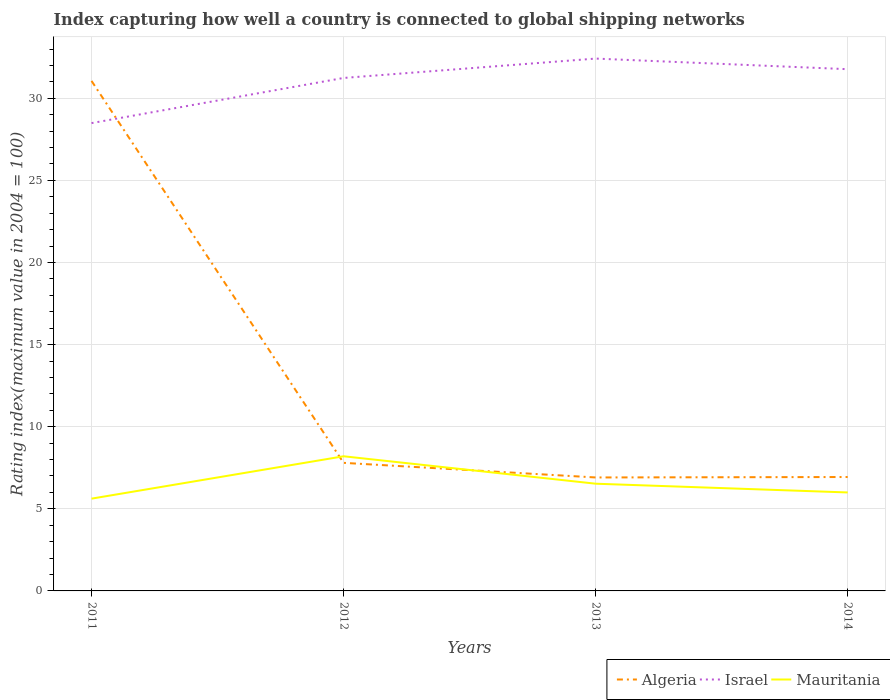Is the number of lines equal to the number of legend labels?
Give a very brief answer. Yes. Across all years, what is the maximum rating index in Mauritania?
Offer a very short reply. 5.62. What is the total rating index in Mauritania in the graph?
Keep it short and to the point. 0.53. What is the difference between the highest and the second highest rating index in Israel?
Provide a short and direct response. 3.93. Does the graph contain any zero values?
Make the answer very short. No. Does the graph contain grids?
Offer a terse response. Yes. What is the title of the graph?
Offer a very short reply. Index capturing how well a country is connected to global shipping networks. What is the label or title of the Y-axis?
Give a very brief answer. Rating index(maximum value in 2004 = 100). What is the Rating index(maximum value in 2004 = 100) of Algeria in 2011?
Keep it short and to the point. 31.06. What is the Rating index(maximum value in 2004 = 100) of Israel in 2011?
Offer a terse response. 28.49. What is the Rating index(maximum value in 2004 = 100) in Mauritania in 2011?
Your answer should be very brief. 5.62. What is the Rating index(maximum value in 2004 = 100) of Israel in 2012?
Offer a very short reply. 31.24. What is the Rating index(maximum value in 2004 = 100) in Algeria in 2013?
Offer a very short reply. 6.91. What is the Rating index(maximum value in 2004 = 100) in Israel in 2013?
Provide a short and direct response. 32.42. What is the Rating index(maximum value in 2004 = 100) of Mauritania in 2013?
Your answer should be compact. 6.53. What is the Rating index(maximum value in 2004 = 100) of Algeria in 2014?
Provide a short and direct response. 6.94. What is the Rating index(maximum value in 2004 = 100) of Israel in 2014?
Offer a very short reply. 31.77. What is the Rating index(maximum value in 2004 = 100) of Mauritania in 2014?
Your response must be concise. 6. Across all years, what is the maximum Rating index(maximum value in 2004 = 100) of Algeria?
Offer a very short reply. 31.06. Across all years, what is the maximum Rating index(maximum value in 2004 = 100) in Israel?
Keep it short and to the point. 32.42. Across all years, what is the maximum Rating index(maximum value in 2004 = 100) in Mauritania?
Your answer should be compact. 8.2. Across all years, what is the minimum Rating index(maximum value in 2004 = 100) of Algeria?
Ensure brevity in your answer.  6.91. Across all years, what is the minimum Rating index(maximum value in 2004 = 100) in Israel?
Make the answer very short. 28.49. Across all years, what is the minimum Rating index(maximum value in 2004 = 100) of Mauritania?
Offer a terse response. 5.62. What is the total Rating index(maximum value in 2004 = 100) of Algeria in the graph?
Make the answer very short. 52.71. What is the total Rating index(maximum value in 2004 = 100) of Israel in the graph?
Your answer should be very brief. 123.92. What is the total Rating index(maximum value in 2004 = 100) in Mauritania in the graph?
Provide a succinct answer. 26.35. What is the difference between the Rating index(maximum value in 2004 = 100) in Algeria in 2011 and that in 2012?
Offer a terse response. 23.26. What is the difference between the Rating index(maximum value in 2004 = 100) of Israel in 2011 and that in 2012?
Your response must be concise. -2.75. What is the difference between the Rating index(maximum value in 2004 = 100) in Mauritania in 2011 and that in 2012?
Offer a terse response. -2.58. What is the difference between the Rating index(maximum value in 2004 = 100) in Algeria in 2011 and that in 2013?
Keep it short and to the point. 24.15. What is the difference between the Rating index(maximum value in 2004 = 100) of Israel in 2011 and that in 2013?
Your answer should be compact. -3.93. What is the difference between the Rating index(maximum value in 2004 = 100) of Mauritania in 2011 and that in 2013?
Offer a very short reply. -0.91. What is the difference between the Rating index(maximum value in 2004 = 100) in Algeria in 2011 and that in 2014?
Your response must be concise. 24.12. What is the difference between the Rating index(maximum value in 2004 = 100) of Israel in 2011 and that in 2014?
Keep it short and to the point. -3.28. What is the difference between the Rating index(maximum value in 2004 = 100) in Mauritania in 2011 and that in 2014?
Offer a terse response. -0.38. What is the difference between the Rating index(maximum value in 2004 = 100) in Algeria in 2012 and that in 2013?
Give a very brief answer. 0.89. What is the difference between the Rating index(maximum value in 2004 = 100) in Israel in 2012 and that in 2013?
Ensure brevity in your answer.  -1.18. What is the difference between the Rating index(maximum value in 2004 = 100) of Mauritania in 2012 and that in 2013?
Give a very brief answer. 1.67. What is the difference between the Rating index(maximum value in 2004 = 100) of Algeria in 2012 and that in 2014?
Provide a succinct answer. 0.86. What is the difference between the Rating index(maximum value in 2004 = 100) in Israel in 2012 and that in 2014?
Provide a short and direct response. -0.53. What is the difference between the Rating index(maximum value in 2004 = 100) in Mauritania in 2012 and that in 2014?
Ensure brevity in your answer.  2.2. What is the difference between the Rating index(maximum value in 2004 = 100) of Algeria in 2013 and that in 2014?
Your answer should be very brief. -0.03. What is the difference between the Rating index(maximum value in 2004 = 100) in Israel in 2013 and that in 2014?
Make the answer very short. 0.65. What is the difference between the Rating index(maximum value in 2004 = 100) of Mauritania in 2013 and that in 2014?
Your answer should be compact. 0.53. What is the difference between the Rating index(maximum value in 2004 = 100) in Algeria in 2011 and the Rating index(maximum value in 2004 = 100) in Israel in 2012?
Your answer should be very brief. -0.18. What is the difference between the Rating index(maximum value in 2004 = 100) of Algeria in 2011 and the Rating index(maximum value in 2004 = 100) of Mauritania in 2012?
Your response must be concise. 22.86. What is the difference between the Rating index(maximum value in 2004 = 100) in Israel in 2011 and the Rating index(maximum value in 2004 = 100) in Mauritania in 2012?
Keep it short and to the point. 20.29. What is the difference between the Rating index(maximum value in 2004 = 100) in Algeria in 2011 and the Rating index(maximum value in 2004 = 100) in Israel in 2013?
Offer a terse response. -1.36. What is the difference between the Rating index(maximum value in 2004 = 100) of Algeria in 2011 and the Rating index(maximum value in 2004 = 100) of Mauritania in 2013?
Your answer should be compact. 24.53. What is the difference between the Rating index(maximum value in 2004 = 100) of Israel in 2011 and the Rating index(maximum value in 2004 = 100) of Mauritania in 2013?
Your response must be concise. 21.96. What is the difference between the Rating index(maximum value in 2004 = 100) of Algeria in 2011 and the Rating index(maximum value in 2004 = 100) of Israel in 2014?
Give a very brief answer. -0.71. What is the difference between the Rating index(maximum value in 2004 = 100) in Algeria in 2011 and the Rating index(maximum value in 2004 = 100) in Mauritania in 2014?
Offer a terse response. 25.06. What is the difference between the Rating index(maximum value in 2004 = 100) of Israel in 2011 and the Rating index(maximum value in 2004 = 100) of Mauritania in 2014?
Provide a short and direct response. 22.49. What is the difference between the Rating index(maximum value in 2004 = 100) in Algeria in 2012 and the Rating index(maximum value in 2004 = 100) in Israel in 2013?
Provide a succinct answer. -24.62. What is the difference between the Rating index(maximum value in 2004 = 100) in Algeria in 2012 and the Rating index(maximum value in 2004 = 100) in Mauritania in 2013?
Your response must be concise. 1.27. What is the difference between the Rating index(maximum value in 2004 = 100) of Israel in 2012 and the Rating index(maximum value in 2004 = 100) of Mauritania in 2013?
Ensure brevity in your answer.  24.71. What is the difference between the Rating index(maximum value in 2004 = 100) of Algeria in 2012 and the Rating index(maximum value in 2004 = 100) of Israel in 2014?
Keep it short and to the point. -23.97. What is the difference between the Rating index(maximum value in 2004 = 100) in Algeria in 2012 and the Rating index(maximum value in 2004 = 100) in Mauritania in 2014?
Provide a short and direct response. 1.8. What is the difference between the Rating index(maximum value in 2004 = 100) of Israel in 2012 and the Rating index(maximum value in 2004 = 100) of Mauritania in 2014?
Your answer should be compact. 25.24. What is the difference between the Rating index(maximum value in 2004 = 100) of Algeria in 2013 and the Rating index(maximum value in 2004 = 100) of Israel in 2014?
Provide a short and direct response. -24.86. What is the difference between the Rating index(maximum value in 2004 = 100) of Algeria in 2013 and the Rating index(maximum value in 2004 = 100) of Mauritania in 2014?
Keep it short and to the point. 0.91. What is the difference between the Rating index(maximum value in 2004 = 100) of Israel in 2013 and the Rating index(maximum value in 2004 = 100) of Mauritania in 2014?
Keep it short and to the point. 26.42. What is the average Rating index(maximum value in 2004 = 100) of Algeria per year?
Offer a very short reply. 13.18. What is the average Rating index(maximum value in 2004 = 100) of Israel per year?
Your answer should be compact. 30.98. What is the average Rating index(maximum value in 2004 = 100) of Mauritania per year?
Offer a very short reply. 6.59. In the year 2011, what is the difference between the Rating index(maximum value in 2004 = 100) of Algeria and Rating index(maximum value in 2004 = 100) of Israel?
Your answer should be compact. 2.57. In the year 2011, what is the difference between the Rating index(maximum value in 2004 = 100) in Algeria and Rating index(maximum value in 2004 = 100) in Mauritania?
Offer a terse response. 25.44. In the year 2011, what is the difference between the Rating index(maximum value in 2004 = 100) of Israel and Rating index(maximum value in 2004 = 100) of Mauritania?
Offer a terse response. 22.87. In the year 2012, what is the difference between the Rating index(maximum value in 2004 = 100) of Algeria and Rating index(maximum value in 2004 = 100) of Israel?
Provide a succinct answer. -23.44. In the year 2012, what is the difference between the Rating index(maximum value in 2004 = 100) in Algeria and Rating index(maximum value in 2004 = 100) in Mauritania?
Offer a terse response. -0.4. In the year 2012, what is the difference between the Rating index(maximum value in 2004 = 100) in Israel and Rating index(maximum value in 2004 = 100) in Mauritania?
Your response must be concise. 23.04. In the year 2013, what is the difference between the Rating index(maximum value in 2004 = 100) in Algeria and Rating index(maximum value in 2004 = 100) in Israel?
Your response must be concise. -25.51. In the year 2013, what is the difference between the Rating index(maximum value in 2004 = 100) in Algeria and Rating index(maximum value in 2004 = 100) in Mauritania?
Provide a short and direct response. 0.38. In the year 2013, what is the difference between the Rating index(maximum value in 2004 = 100) in Israel and Rating index(maximum value in 2004 = 100) in Mauritania?
Provide a short and direct response. 25.89. In the year 2014, what is the difference between the Rating index(maximum value in 2004 = 100) of Algeria and Rating index(maximum value in 2004 = 100) of Israel?
Your answer should be very brief. -24.84. In the year 2014, what is the difference between the Rating index(maximum value in 2004 = 100) in Algeria and Rating index(maximum value in 2004 = 100) in Mauritania?
Make the answer very short. 0.94. In the year 2014, what is the difference between the Rating index(maximum value in 2004 = 100) of Israel and Rating index(maximum value in 2004 = 100) of Mauritania?
Give a very brief answer. 25.78. What is the ratio of the Rating index(maximum value in 2004 = 100) of Algeria in 2011 to that in 2012?
Make the answer very short. 3.98. What is the ratio of the Rating index(maximum value in 2004 = 100) in Israel in 2011 to that in 2012?
Offer a terse response. 0.91. What is the ratio of the Rating index(maximum value in 2004 = 100) of Mauritania in 2011 to that in 2012?
Provide a succinct answer. 0.69. What is the ratio of the Rating index(maximum value in 2004 = 100) in Algeria in 2011 to that in 2013?
Offer a very short reply. 4.49. What is the ratio of the Rating index(maximum value in 2004 = 100) of Israel in 2011 to that in 2013?
Offer a very short reply. 0.88. What is the ratio of the Rating index(maximum value in 2004 = 100) in Mauritania in 2011 to that in 2013?
Give a very brief answer. 0.86. What is the ratio of the Rating index(maximum value in 2004 = 100) of Algeria in 2011 to that in 2014?
Provide a succinct answer. 4.48. What is the ratio of the Rating index(maximum value in 2004 = 100) of Israel in 2011 to that in 2014?
Keep it short and to the point. 0.9. What is the ratio of the Rating index(maximum value in 2004 = 100) in Mauritania in 2011 to that in 2014?
Provide a succinct answer. 0.94. What is the ratio of the Rating index(maximum value in 2004 = 100) in Algeria in 2012 to that in 2013?
Your answer should be very brief. 1.13. What is the ratio of the Rating index(maximum value in 2004 = 100) of Israel in 2012 to that in 2013?
Keep it short and to the point. 0.96. What is the ratio of the Rating index(maximum value in 2004 = 100) in Mauritania in 2012 to that in 2013?
Ensure brevity in your answer.  1.26. What is the ratio of the Rating index(maximum value in 2004 = 100) of Algeria in 2012 to that in 2014?
Your response must be concise. 1.12. What is the ratio of the Rating index(maximum value in 2004 = 100) in Israel in 2012 to that in 2014?
Make the answer very short. 0.98. What is the ratio of the Rating index(maximum value in 2004 = 100) in Mauritania in 2012 to that in 2014?
Your answer should be very brief. 1.37. What is the ratio of the Rating index(maximum value in 2004 = 100) in Israel in 2013 to that in 2014?
Ensure brevity in your answer.  1.02. What is the ratio of the Rating index(maximum value in 2004 = 100) of Mauritania in 2013 to that in 2014?
Your answer should be very brief. 1.09. What is the difference between the highest and the second highest Rating index(maximum value in 2004 = 100) of Algeria?
Your answer should be very brief. 23.26. What is the difference between the highest and the second highest Rating index(maximum value in 2004 = 100) of Israel?
Offer a very short reply. 0.65. What is the difference between the highest and the second highest Rating index(maximum value in 2004 = 100) of Mauritania?
Your response must be concise. 1.67. What is the difference between the highest and the lowest Rating index(maximum value in 2004 = 100) in Algeria?
Provide a short and direct response. 24.15. What is the difference between the highest and the lowest Rating index(maximum value in 2004 = 100) of Israel?
Your response must be concise. 3.93. What is the difference between the highest and the lowest Rating index(maximum value in 2004 = 100) in Mauritania?
Your answer should be very brief. 2.58. 